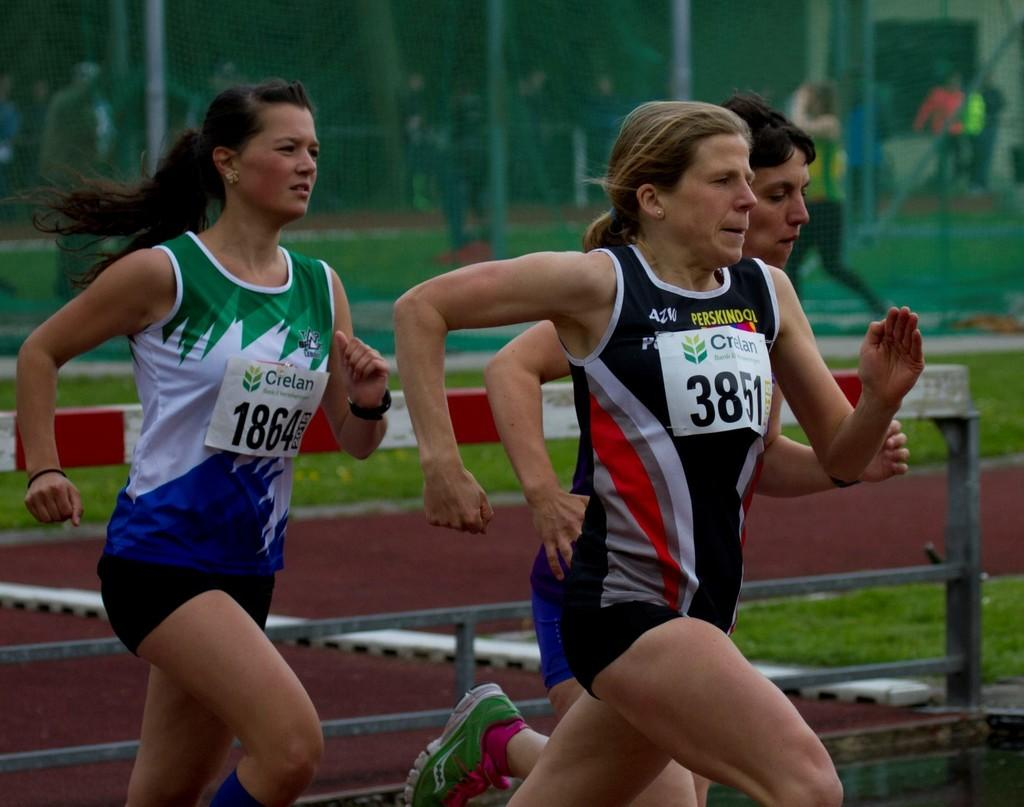<image>
Describe the image concisely. a runner with the numbers 3 and 8 on their shirt 